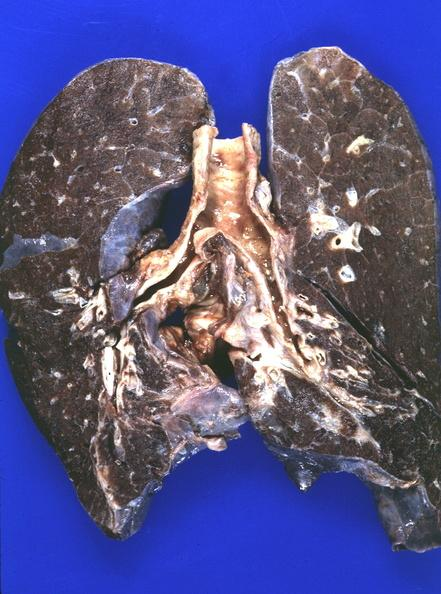what is present?
Answer the question using a single word or phrase. Respiratory 